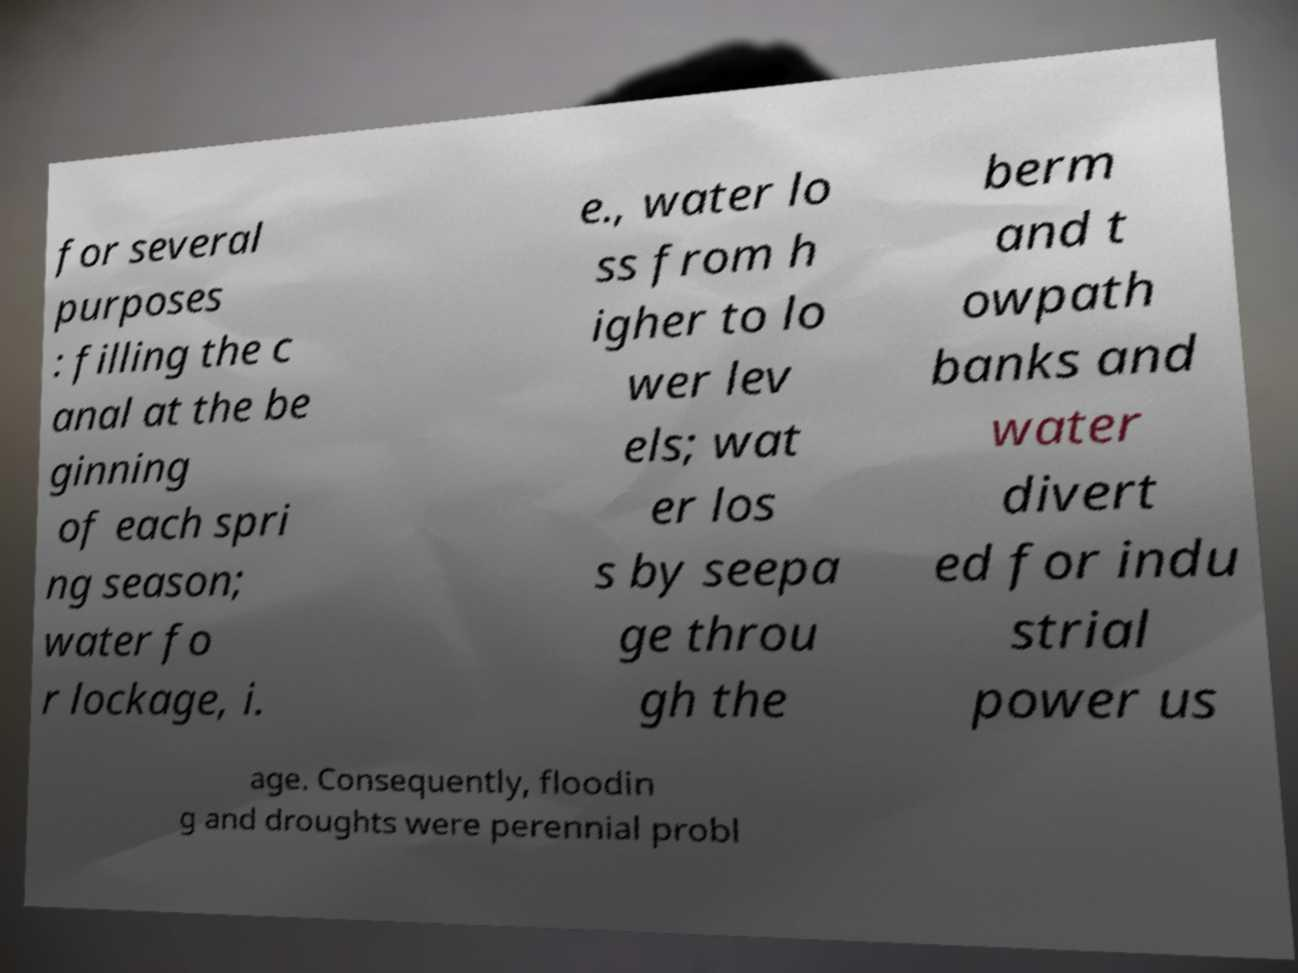Could you assist in decoding the text presented in this image and type it out clearly? for several purposes : filling the c anal at the be ginning of each spri ng season; water fo r lockage, i. e., water lo ss from h igher to lo wer lev els; wat er los s by seepa ge throu gh the berm and t owpath banks and water divert ed for indu strial power us age. Consequently, floodin g and droughts were perennial probl 